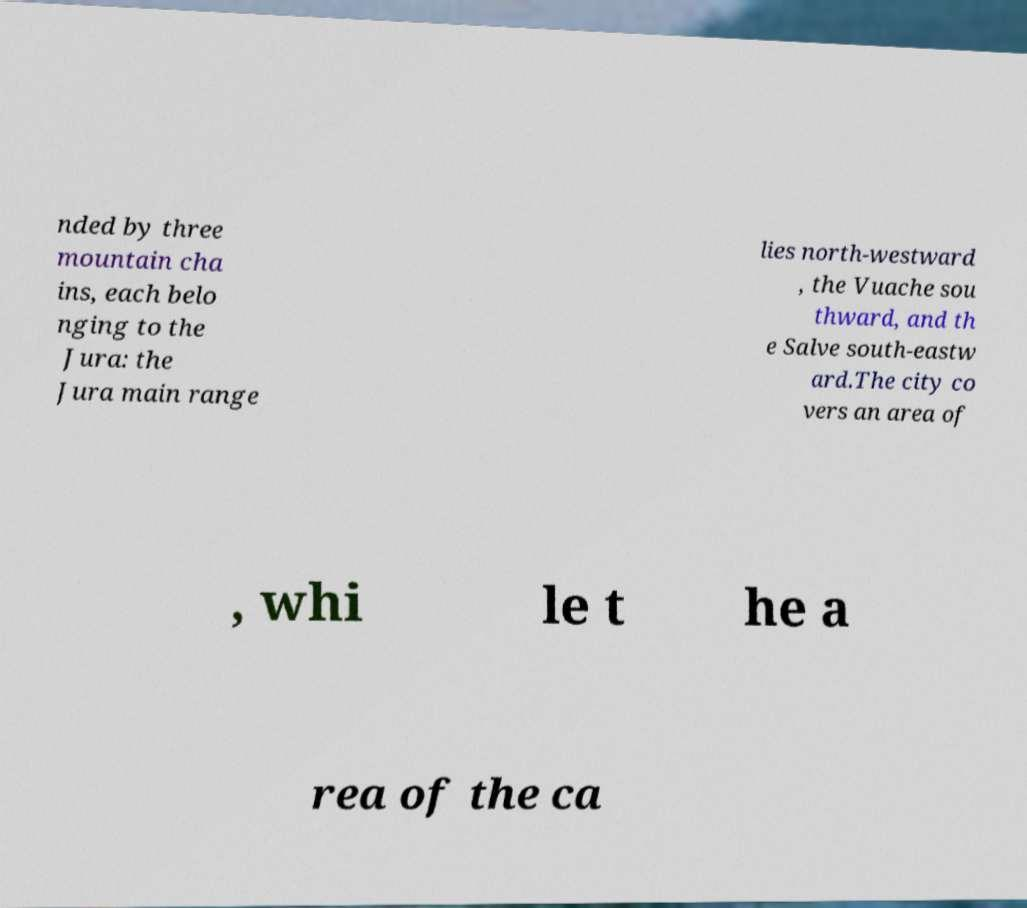What messages or text are displayed in this image? I need them in a readable, typed format. nded by three mountain cha ins, each belo nging to the Jura: the Jura main range lies north-westward , the Vuache sou thward, and th e Salve south-eastw ard.The city co vers an area of , whi le t he a rea of the ca 